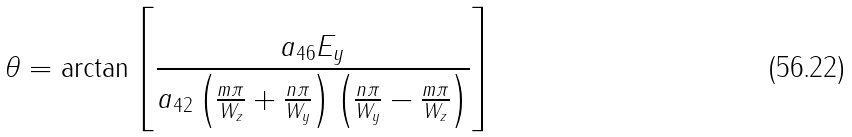Convert formula to latex. <formula><loc_0><loc_0><loc_500><loc_500>\theta = \text {arctan} \left [ \frac { a _ { 4 6 } E _ { y } } { a _ { 4 2 } \left ( \frac { m \pi } { W _ { z } } + \frac { n \pi } { W _ { y } } \right ) \left ( \frac { n \pi } { W _ { y } } - \frac { m \pi } { W _ { z } } \right ) } \right ]</formula> 